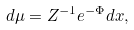<formula> <loc_0><loc_0><loc_500><loc_500>d \mu = Z ^ { - 1 } e ^ { - \Phi } d x ,</formula> 